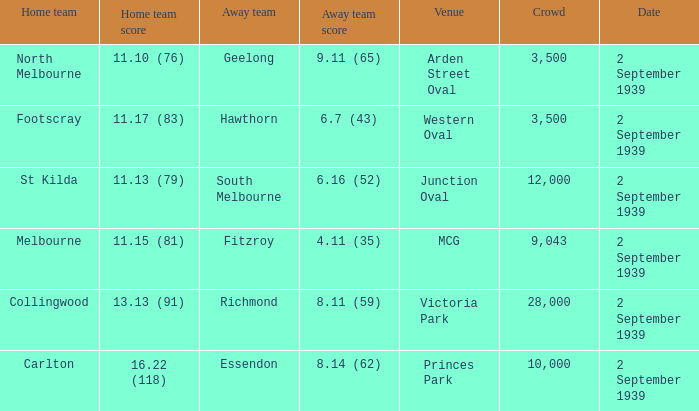What was the crowd size of the match featuring Hawthorn as the Away team? 3500.0. 